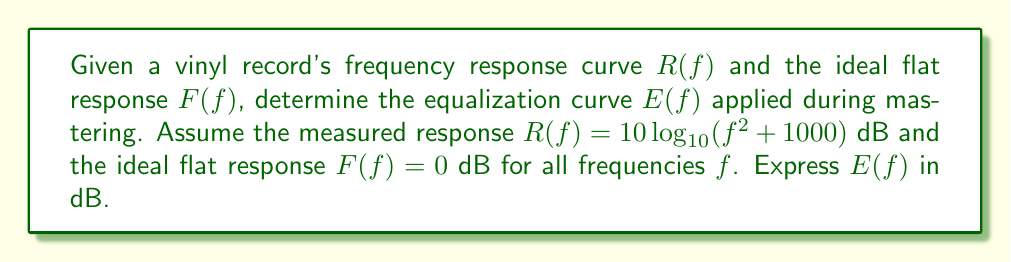Show me your answer to this math problem. To reverse engineer the equalization curve, we need to follow these steps:

1) The relationship between the measured response $R(f)$, the ideal flat response $F(f)$, and the equalization curve $E(f)$ is:

   $R(f) = F(f) + E(f)$

2) We're given that $F(f) = 0$ dB for all frequencies, so:

   $R(f) = E(f)$

3) We know that $R(f) = 10\log_{10}(f^2 + 1000)$ dB

4) Therefore, the equalization curve $E(f)$ is:

   $E(f) = 10\log_{10}(f^2 + 1000)$ dB

5) This equalization curve boosts higher frequencies more than lower frequencies, which is typical in vinyl mastering to compensate for limitations in the vinyl medium.

6) To verify, at low frequencies (e.g., $f = 0$ Hz):
   
   $E(0) = 10\log_{10}(0^2 + 1000) = 10\log_{10}(1000) \approx 30$ dB

   At higher frequencies (e.g., $f = 1000$ Hz):
   
   $E(1000) = 10\log_{10}(1000^2 + 1000) \approx 60$ dB

   This shows a significant boost in higher frequencies, as expected in vinyl mastering.
Answer: $E(f) = 10\log_{10}(f^2 + 1000)$ dB 